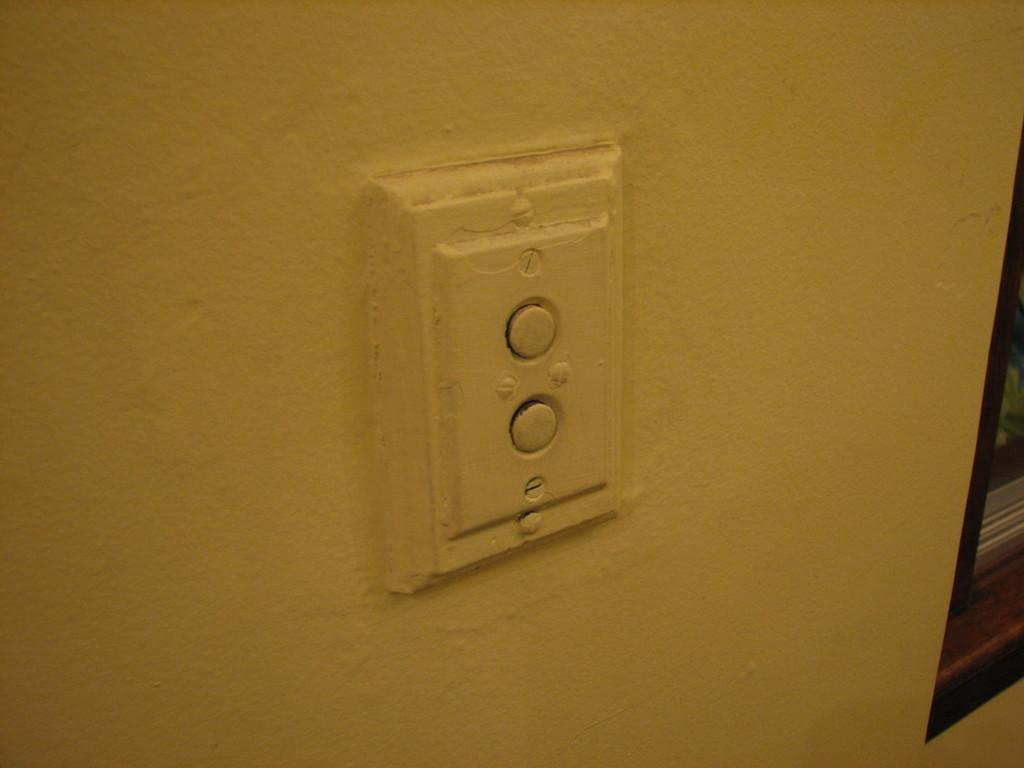What is the main feature of the wall in the image? There is a plain wall in the image. What can be seen attached to the wall? There are screws on the wall. What is located on the right side of the image? There is a window on the right side of the image. What type of loaf is being cooked in the image? There is no loaf or cooking activity present in the image. Who is the birthday person in the image? There is no birthday celebration or person mentioned in the image. 